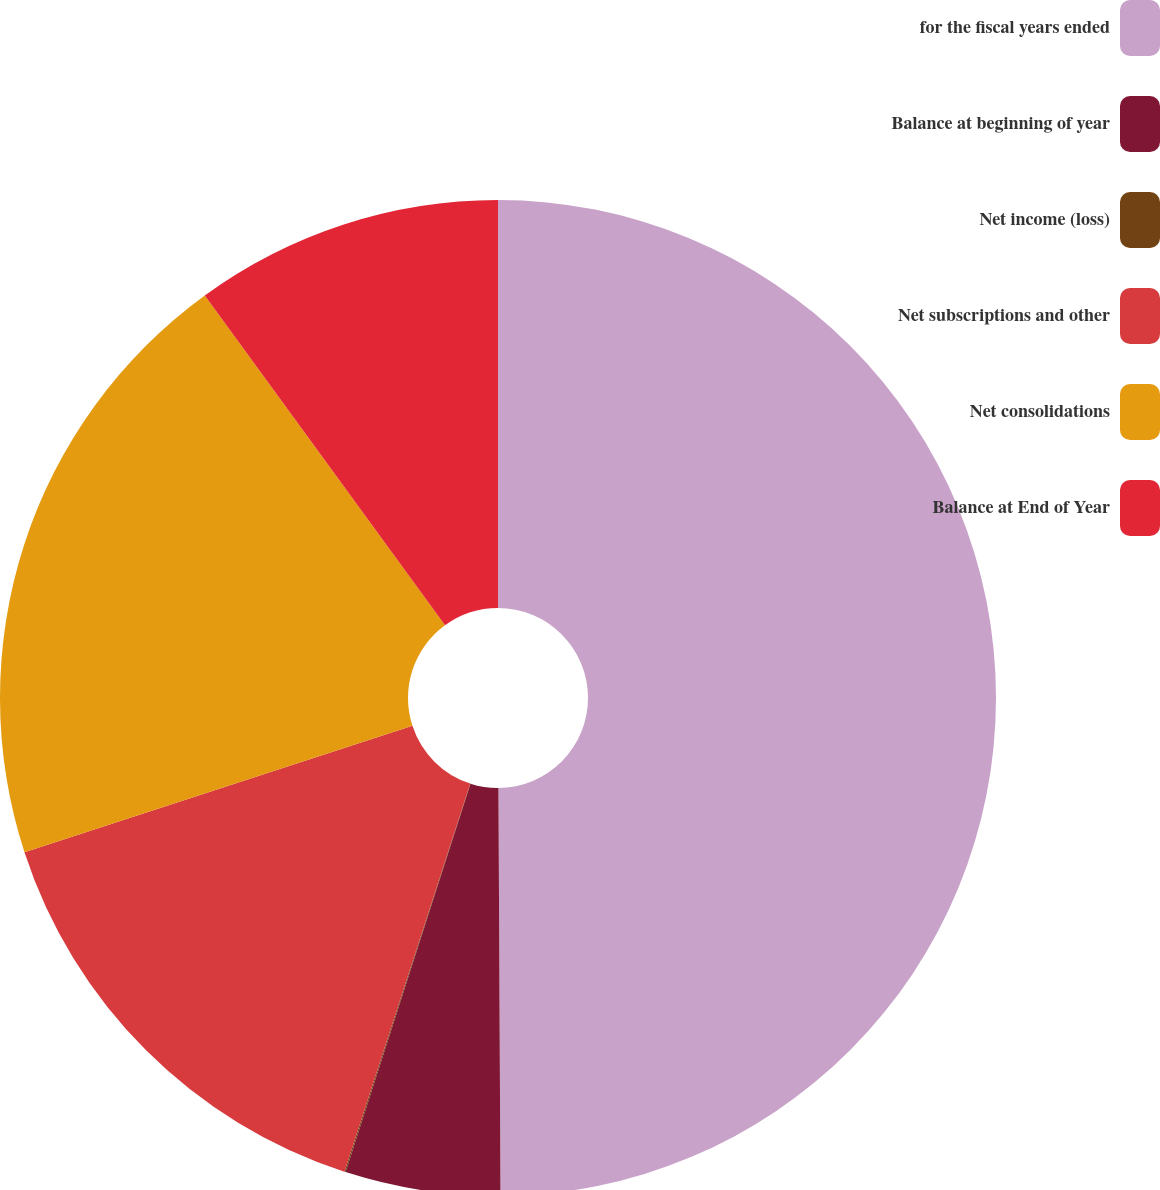Convert chart to OTSL. <chart><loc_0><loc_0><loc_500><loc_500><pie_chart><fcel>for the fiscal years ended<fcel>Balance at beginning of year<fcel>Net income (loss)<fcel>Net subscriptions and other<fcel>Net consolidations<fcel>Balance at End of Year<nl><fcel>49.92%<fcel>5.03%<fcel>0.04%<fcel>15.0%<fcel>19.99%<fcel>10.02%<nl></chart> 